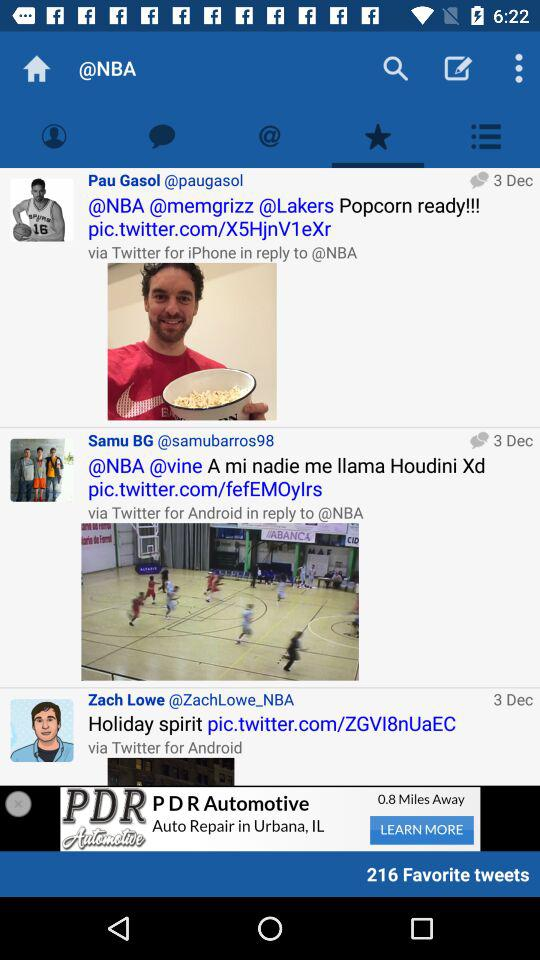What is the date for Pau Gasol's post? The date is December 3. 